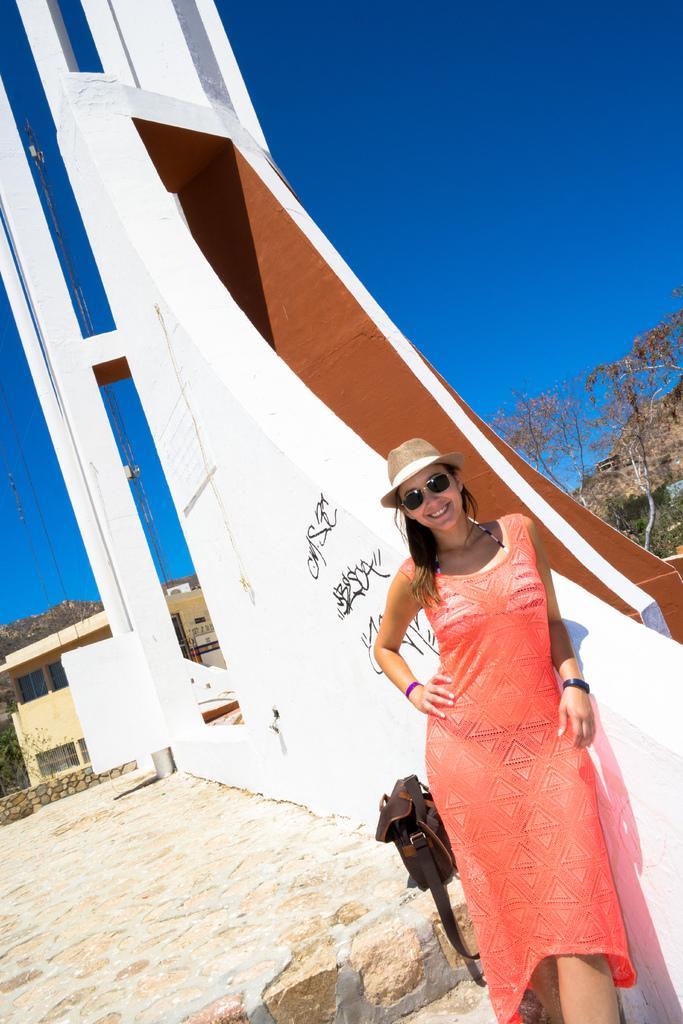Could you give a brief overview of what you see in this image? In this image in the front there is a woman standing and smiling. In the background there is a wall and there is a house and there are trees. 